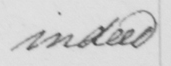Transcribe the text shown in this historical manuscript line. indeed 